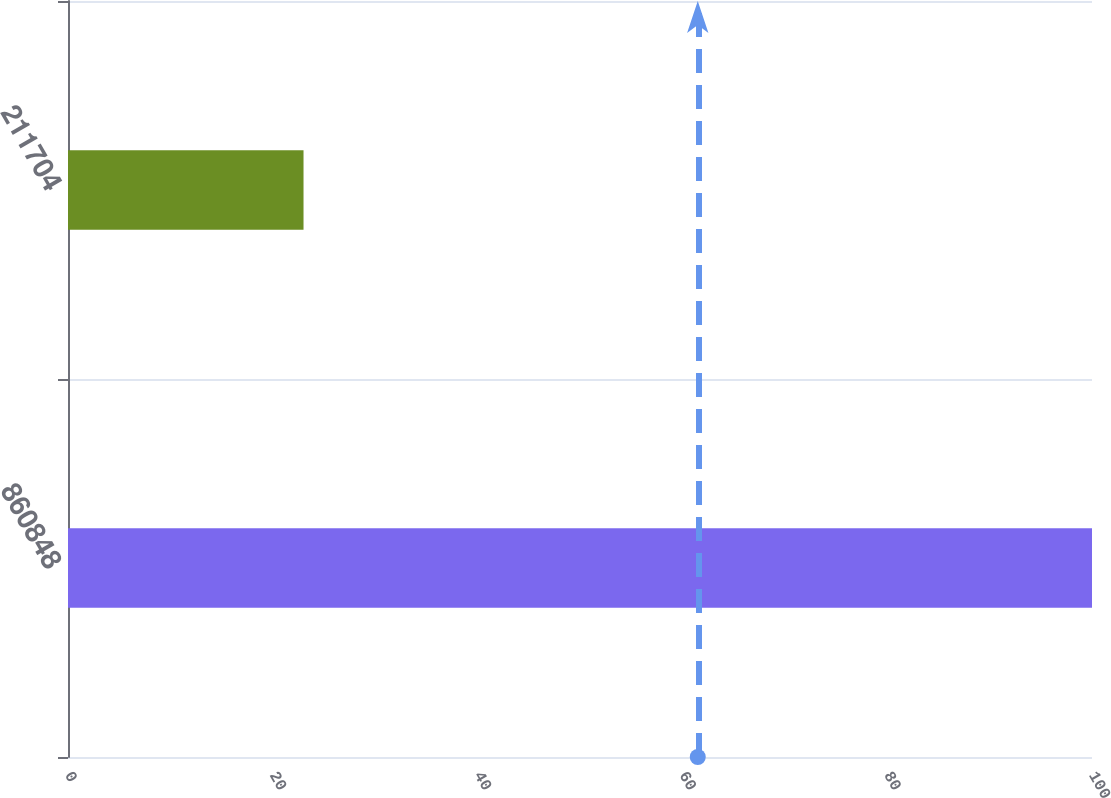Convert chart to OTSL. <chart><loc_0><loc_0><loc_500><loc_500><bar_chart><fcel>860848<fcel>211704<nl><fcel>100<fcel>23<nl></chart> 